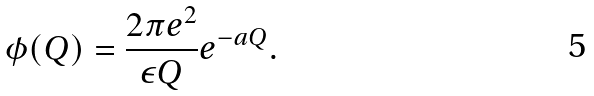Convert formula to latex. <formula><loc_0><loc_0><loc_500><loc_500>\phi ( Q ) = \frac { 2 \pi e ^ { 2 } } { \epsilon Q } e ^ { - a Q } .</formula> 